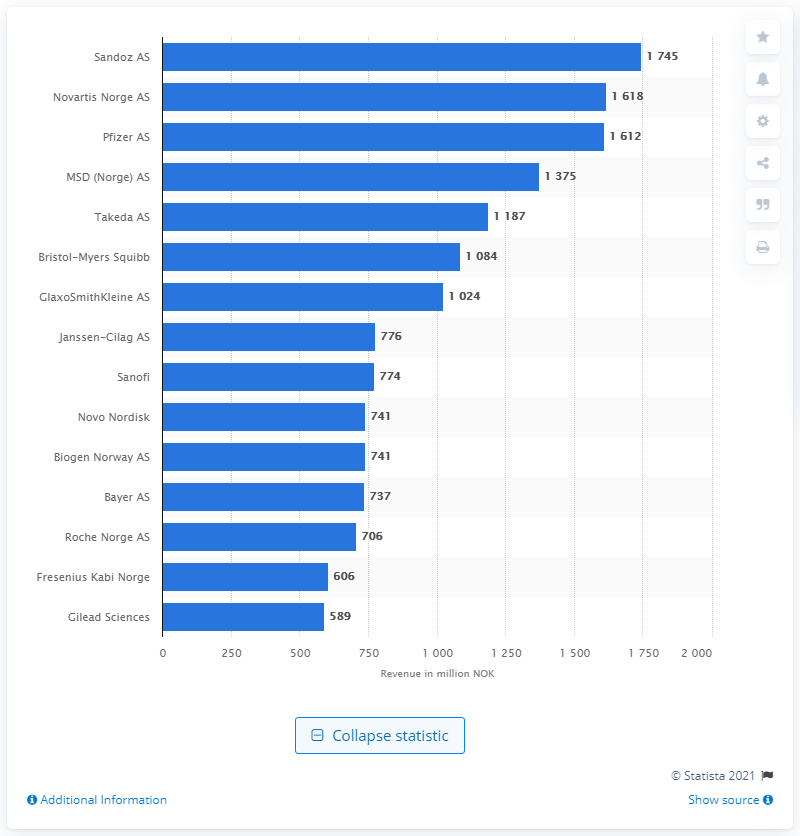List a handful of essential elements in this visual. In 2020, Sandoz AS was the leading pharmaceutical company in Norway. As of 2020, Sandoz AS reported a revenue of 1745 million Norwegian kroner. 